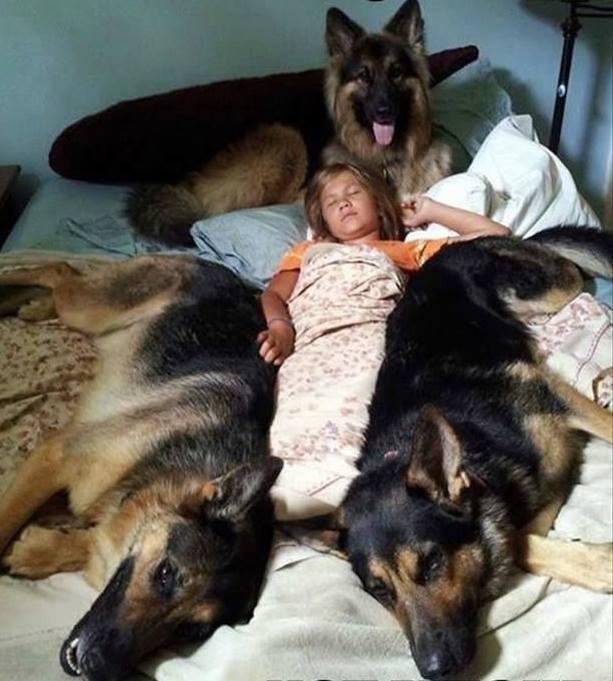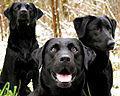The first image is the image on the left, the second image is the image on the right. Assess this claim about the two images: "The right image contains more than one dog, and the left image features a dog with fangs bared in a snarl.". Correct or not? Answer yes or no. No. The first image is the image on the left, the second image is the image on the right. Assess this claim about the two images: "There is no more than two dogs in the right image.". Correct or not? Answer yes or no. No. 